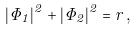Convert formula to latex. <formula><loc_0><loc_0><loc_500><loc_500>| \Phi _ { 1 } | ^ { 2 } + | \Phi _ { 2 } | ^ { 2 } = r \, ,</formula> 